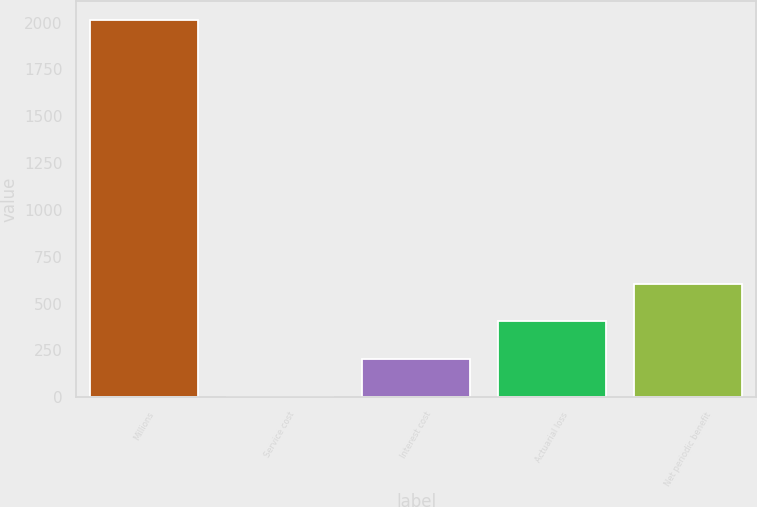<chart> <loc_0><loc_0><loc_500><loc_500><bar_chart><fcel>Millions<fcel>Service cost<fcel>Interest cost<fcel>Actuarial loss<fcel>Net periodic benefit<nl><fcel>2015<fcel>3<fcel>204.2<fcel>405.4<fcel>606.6<nl></chart> 